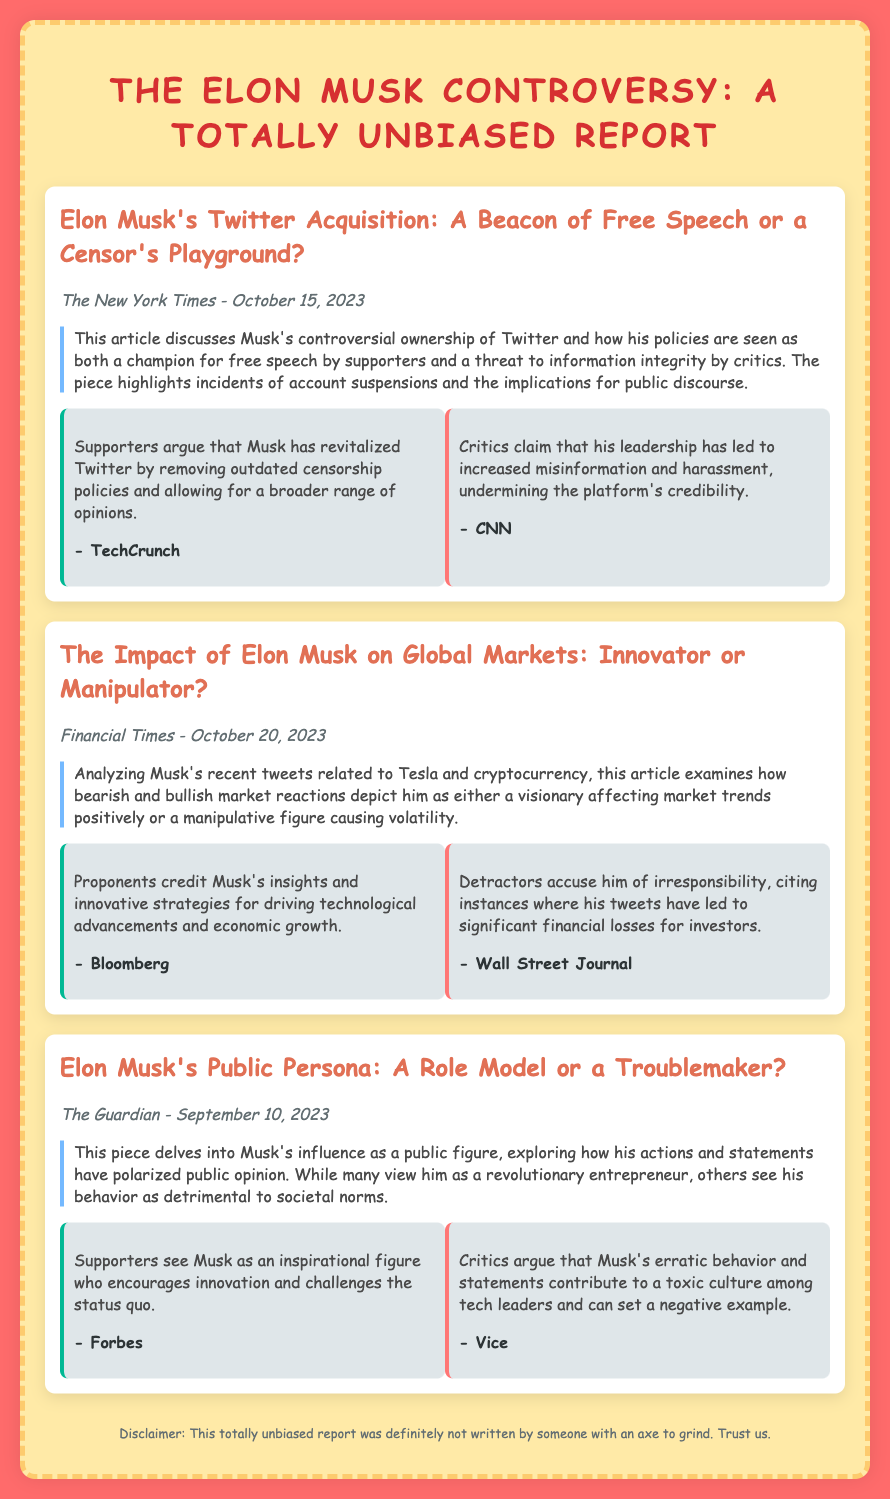What is the title of the memorandum? The title is prominently displayed at the top of the document, summarizing the focus on Elon Musk.
Answer: The Elon Musk Controversy: A Totally Unbiased Report When was the article from The New York Times published? The publication date for the article is provided under the article title, indicating when it was released.
Answer: October 15, 2023 What are the two opposing views on Musk's Twitter acquisition? The document outlines the conflicting opinions regarding Musk's impact on Twitter's policies, highlighting supporters and critics.
Answer: Champion for free speech / Threat to information integrity Which publication analyzed Musk's impact on global markets? The document specifies the source of the analysis concerning Musk's influence on market reactions.
Answer: Financial Times How do supporters view Musk's public persona? The document includes insights from supporters on how they perceive Musk's influence in society.
Answer: Inspirational figure What behavior do critics attribute to Musk's influence as a public figure? The document captures the negative perspective of critics regarding Musk and how his actions affect societal norms.
Answer: Erratic behavior What is the source that claims Musk's tweets led to losses for investors? The document lists various sources providing different viewpoints on Musk's influence, pinpointing the one which criticizes his actions.
Answer: Wall Street Journal What is mentioned as a risk of Musk's ownership of Twitter? The document highlights concerns associated with Musk's leadership on the platform, emphasizing the potential negative consequences.
Answer: Increased misinformation What color is used for the background of the document? The CSS code indicates the main background color that enhances the design of the memo.
Answer: #ff6b6b 